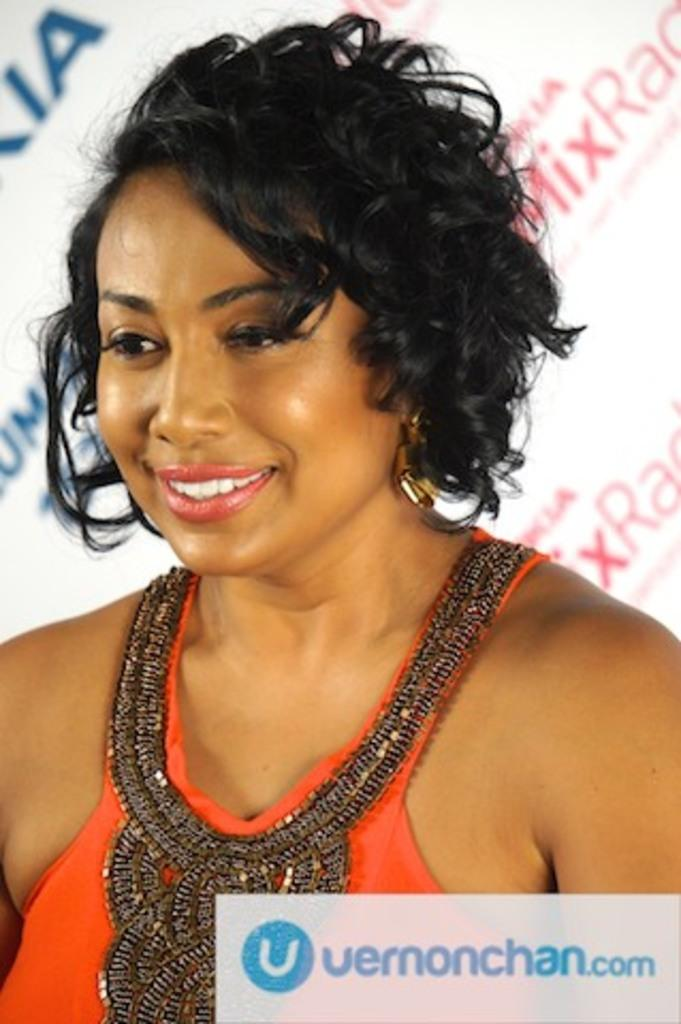What is present in the image? There is a person in the image. What is the person wearing? The person is wearing an orange color dress. What type of linen is the person using to clean the wren in the image? There is no linen or wren present in the image. What type of woman is depicted in the image? The provided facts do not specify the gender of the person in the image. 